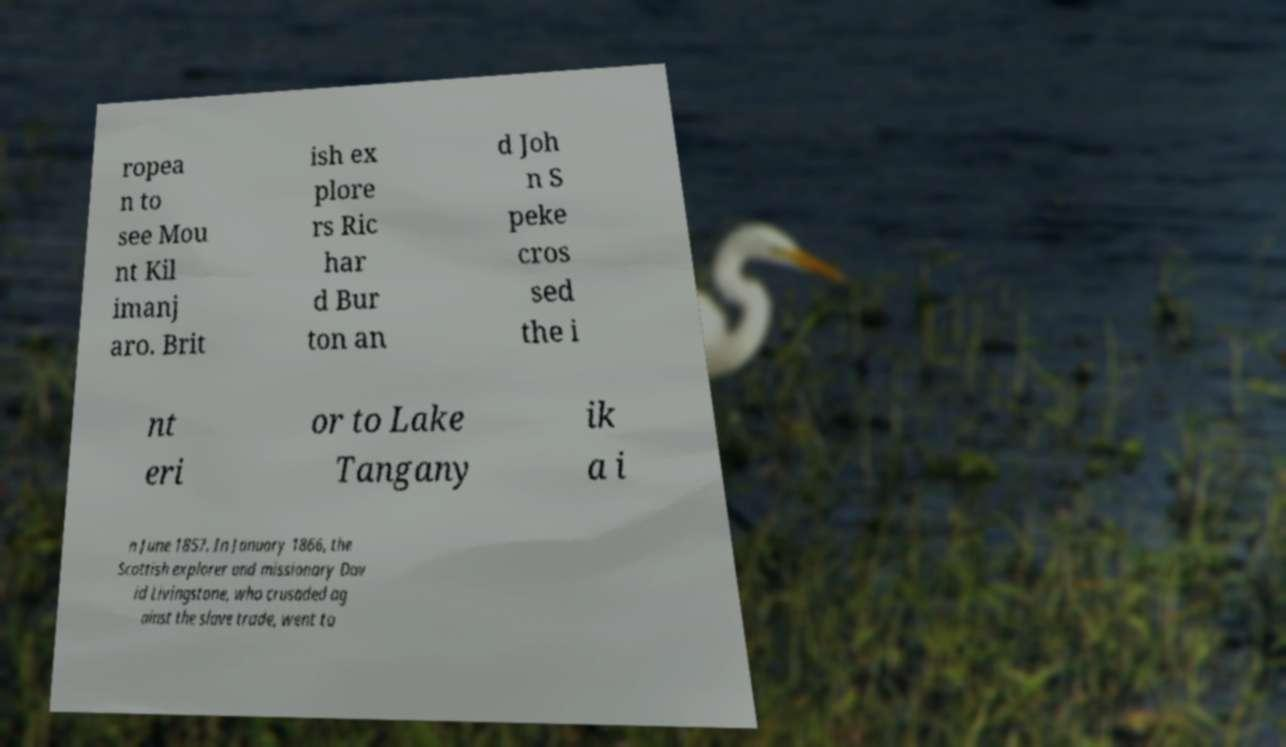Can you accurately transcribe the text from the provided image for me? ropea n to see Mou nt Kil imanj aro. Brit ish ex plore rs Ric har d Bur ton an d Joh n S peke cros sed the i nt eri or to Lake Tangany ik a i n June 1857. In January 1866, the Scottish explorer and missionary Dav id Livingstone, who crusaded ag ainst the slave trade, went to 